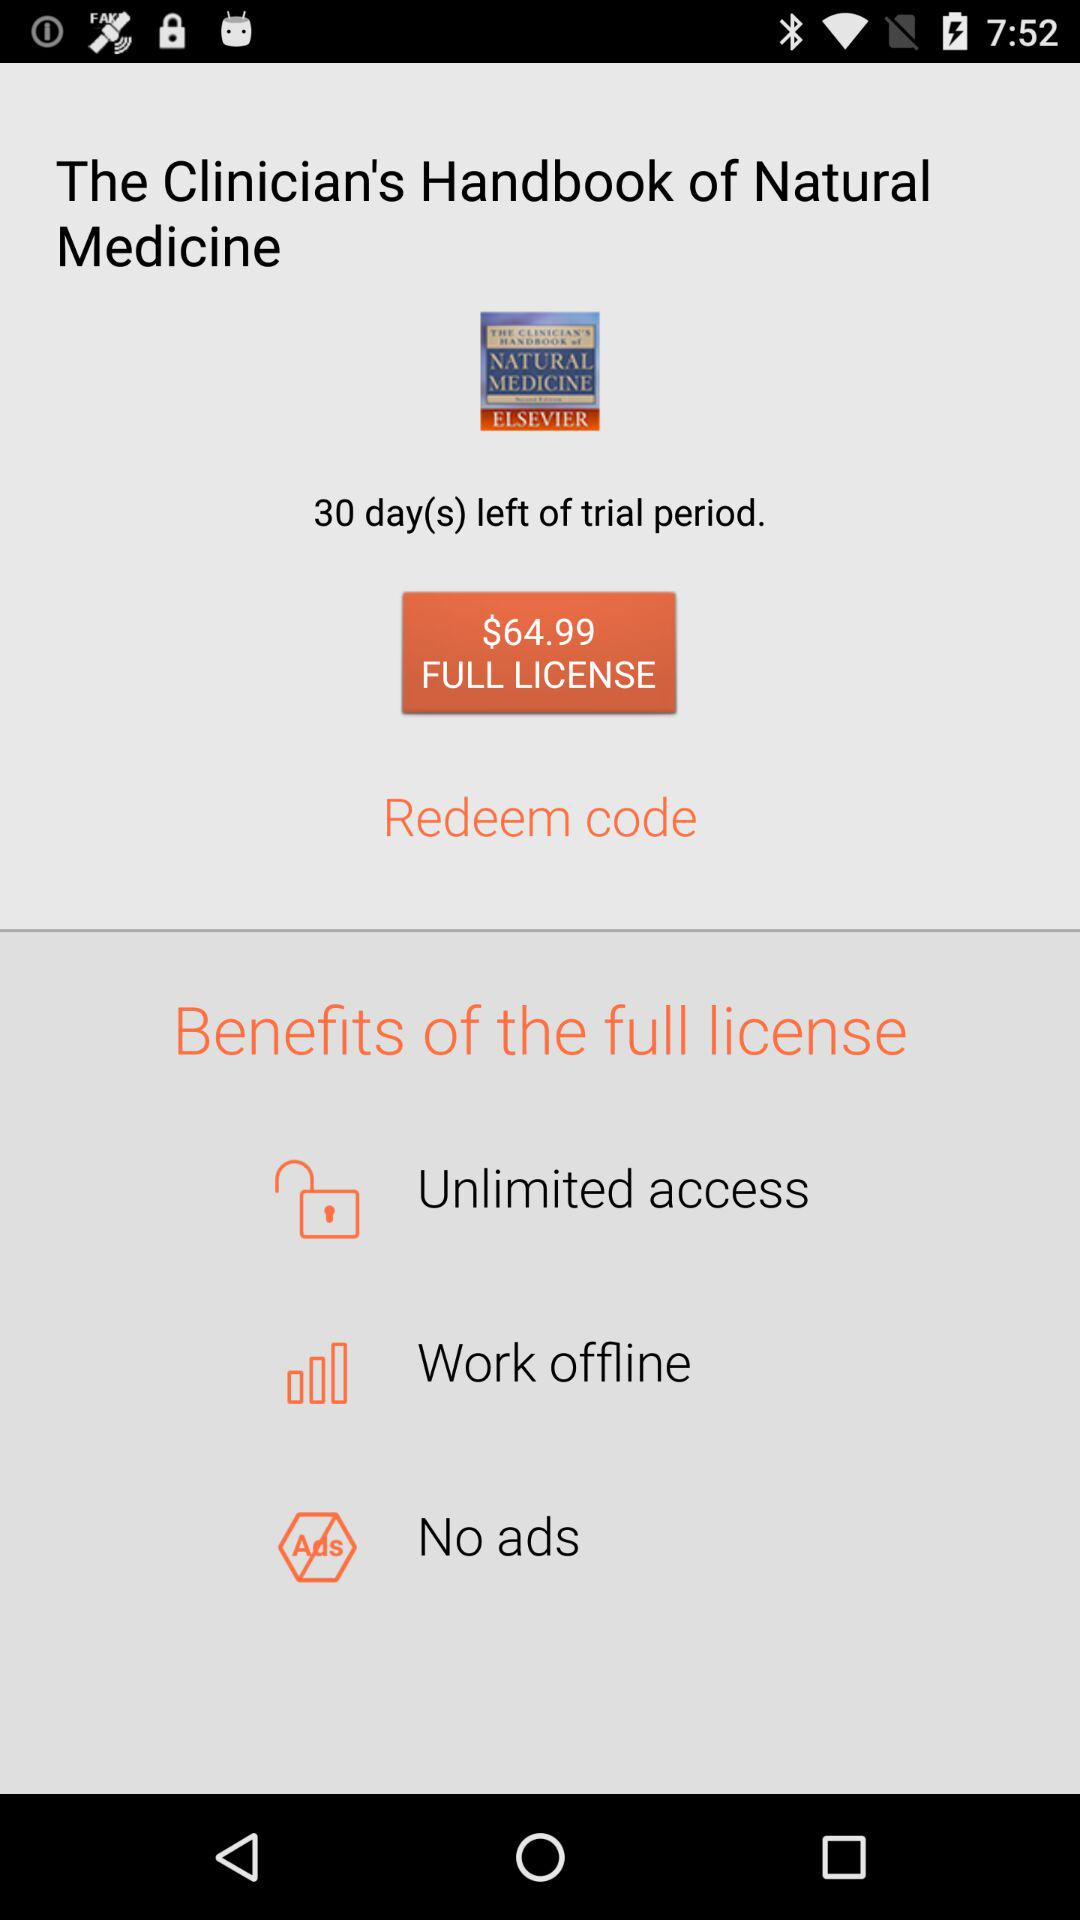What is the price of a full license of "The Clinician's Handbook of Natural Medicine"? The price is $64.99. 